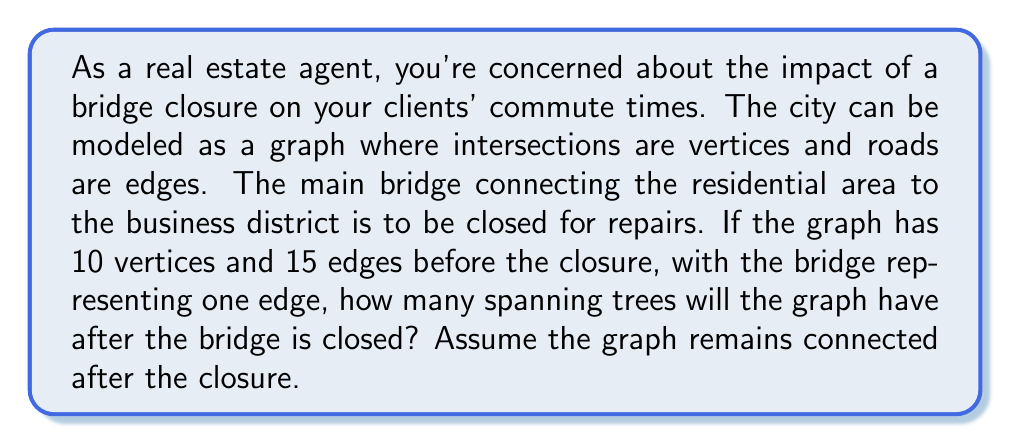Give your solution to this math problem. To solve this problem, we'll use Kirchhoff's Matrix Tree Theorem and the concept of spanning trees in graph theory. Let's approach this step-by-step:

1) Initially, we have a graph $G$ with $|V| = 10$ vertices and $|E| = 15$ edges.

2) After the bridge closure, we'll have a new graph $G'$ with $|V'| = 10$ vertices and $|E'| = 14$ edges.

3) Kirchhoff's Theorem states that the number of spanning trees in a graph is equal to any cofactor of its Laplacian matrix.

4) For a graph with $n$ vertices, the Laplacian matrix $L$ is an $n \times n$ matrix defined as:
   $$L = D - A$$
   where $D$ is the degree matrix and $A$ is the adjacency matrix.

5) In our case, we don't need to construct the actual Laplacian matrix. Instead, we can use a corollary of Kirchhoff's Theorem for complete graphs:
   
   For a complete graph $K_n$, the number of spanning trees is $n^{n-2}$.

6) Our graph $G'$ is not complete, but we can use another result:
   
   If a graph $G$ has $n$ vertices and $m$ edges, the number of spanning trees $t(G)$ is at most:
   $$t(G) \leq \frac{2m}{n} \cdot (\frac{2m-n+1}{n-1})^{n-2}$$

7) Substituting our values: $n = 10$, $m = 14$
   $$t(G') \leq \frac{2(14)}{10} \cdot (\frac{2(14)-10+1}{10-1})^{10-2}$$
   $$t(G') \leq 2.8 \cdot (\frac{19}{9})^8$$
   $$t(G') \leq 2.8 \cdot 42.54 \approx 119$$

8) Since we're asked for an integer number of spanning trees, we round down to 119.

This upper bound gives us an estimate of the maximum number of spanning trees in the modified graph after the bridge closure.
Answer: The graph will have at most 119 spanning trees after the bridge is closed. 